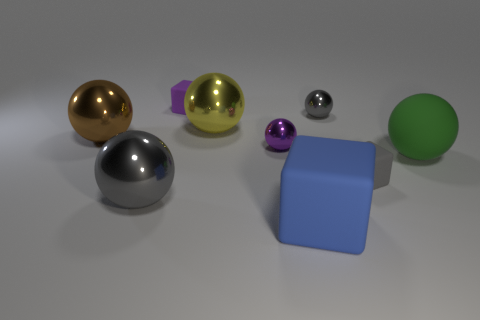What size is the purple cube that is the same material as the blue object?
Keep it short and to the point. Small. How many large things are the same shape as the small purple metal object?
Offer a very short reply. 4. How many metal cylinders are there?
Keep it short and to the point. 0. Does the small gray thing behind the green sphere have the same shape as the large yellow object?
Your answer should be compact. Yes. There is a block that is the same size as the brown ball; what material is it?
Your answer should be very brief. Rubber. Are there any tiny gray things made of the same material as the yellow thing?
Make the answer very short. Yes. Do the small gray shiny object and the tiny shiny thing left of the blue rubber cube have the same shape?
Keep it short and to the point. Yes. What number of things are behind the big yellow ball and right of the big blue rubber object?
Ensure brevity in your answer.  1. Do the blue thing and the small gray object that is behind the brown sphere have the same material?
Offer a very short reply. No. Is the number of tiny purple cubes right of the tiny gray rubber thing the same as the number of tiny purple cylinders?
Make the answer very short. Yes. 